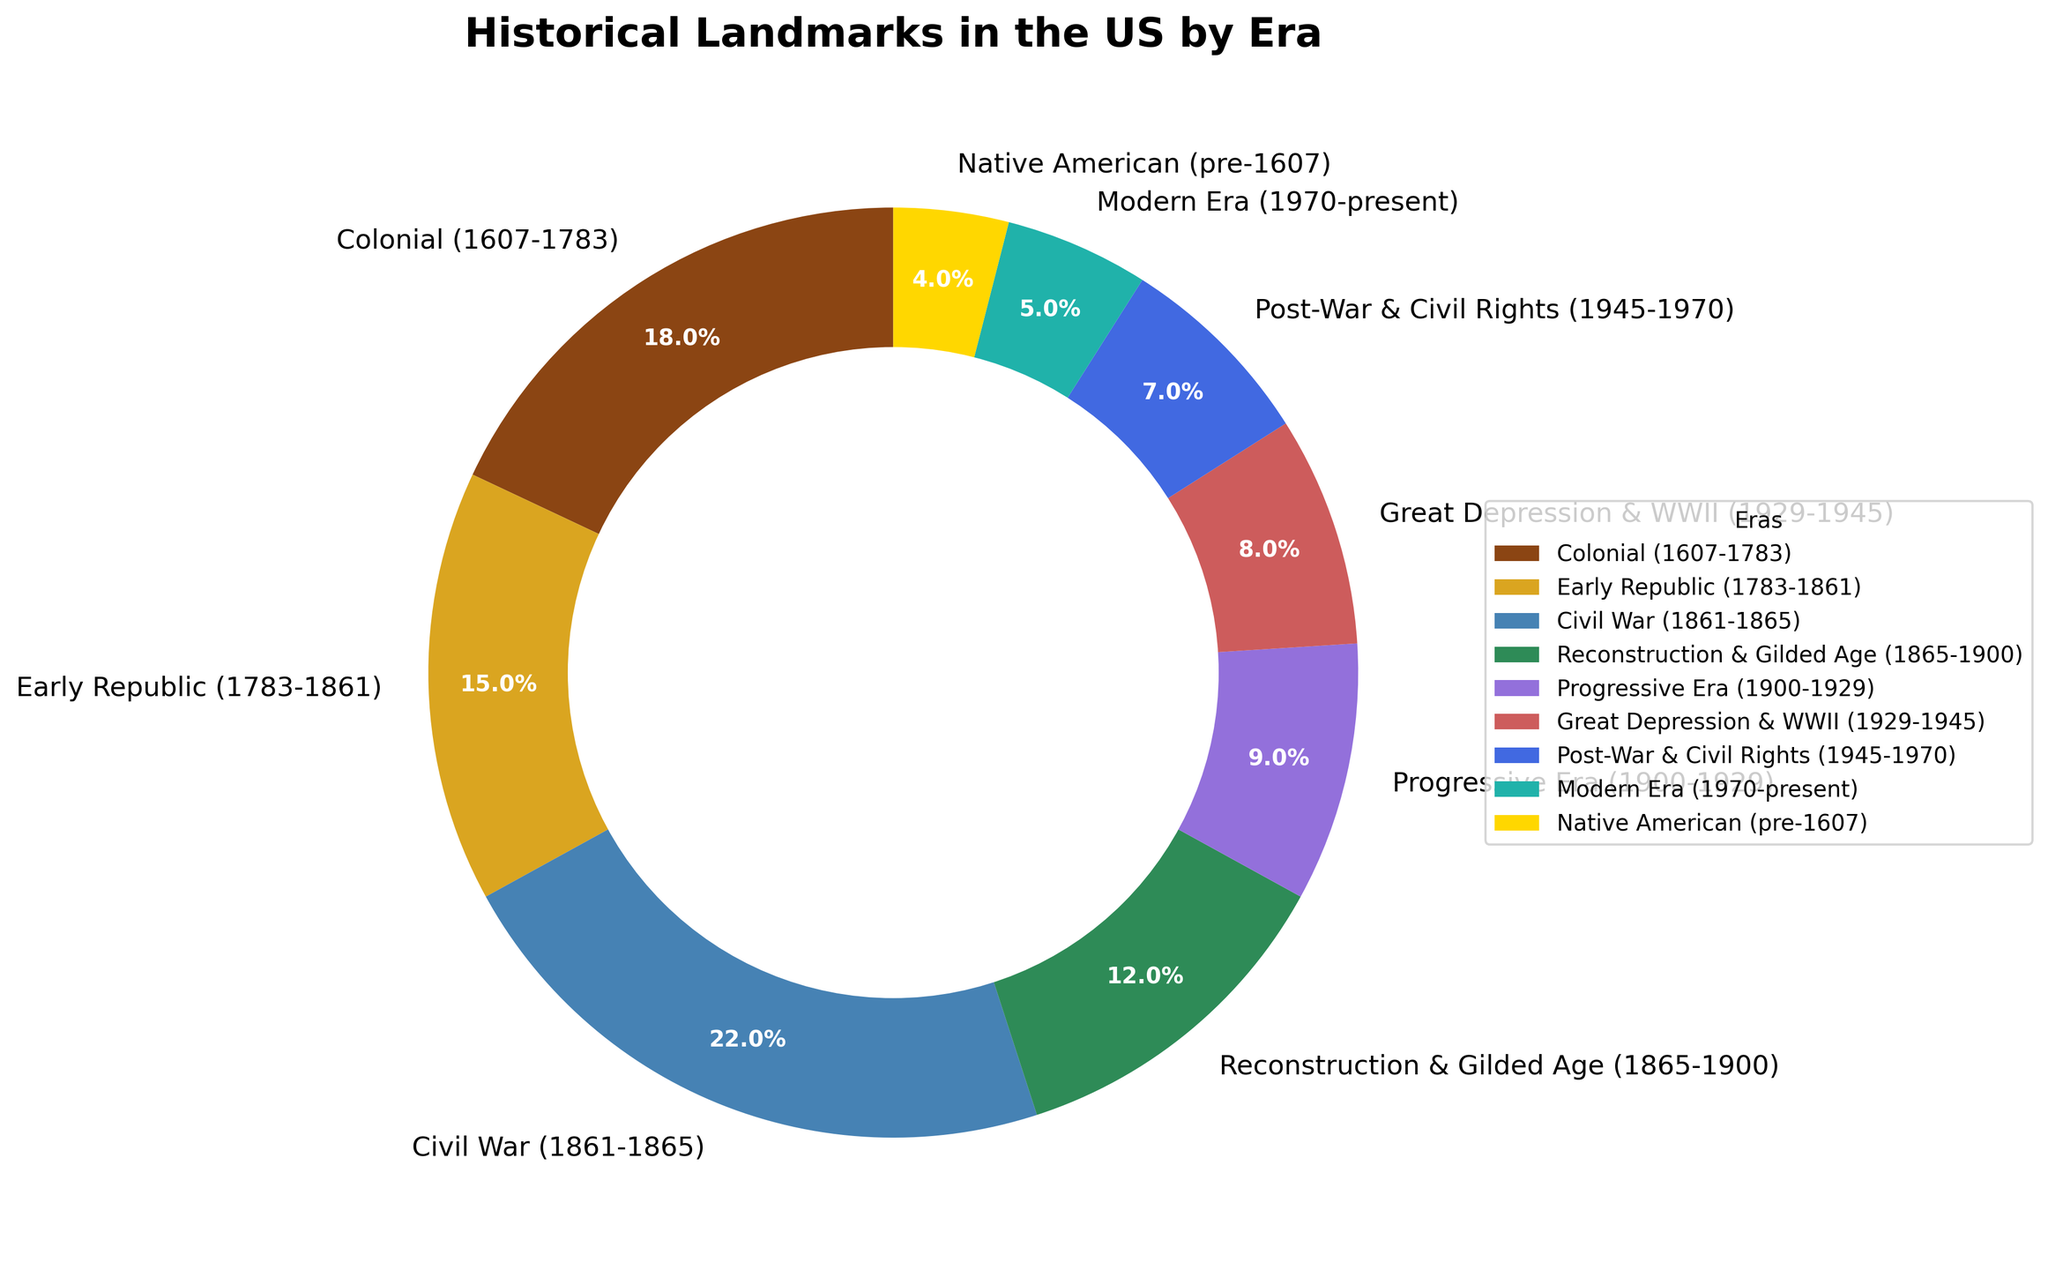Which era has the highest percentage of historical landmarks? Look at the figure, find the percentage associated with each era, and identify the highest one, which is the Civil War era with 22%.
Answer: Civil War era What's the combined percentage of historical landmarks from the Colonial and Civil War eras? Add the percentages of the Colonial and Civil War eras: 18% (Colonial) + 22% (Civil War) = 40%.
Answer: 40% How much higher is the percentage of landmarks from the Civil War era compared to the Native American era? Subtract the percentage of the Native American era from the Civil War era: 22% (Civil War) - 4% (Native American) = 18%.
Answer: 18% Which era has a higher percentage of historical landmarks: the Progressive Era or the Great Depression & WWII era? Compare the percentages: the Progressive Era has 9%, and the Great Depression & WWII era has 8%. The Progressive Era is higher.
Answer: Progressive Era What proportion of the total percentage do the Early Republic and Reconstruction & Gilded Age eras represent together? Add the percentages of the Early Republic and Reconstruction & Gilded Age eras: 15% (Early Republic) + 12% (Reconstruction & Gilded Age) = 27%.
Answer: 27% Is the percentage of landmarks from the Modern Era higher or lower than that of the Post-War & Civil Rights era? Compare the percentages: the Modern Era has 5%, and the Post-War & Civil Rights era has 7%. The Modern Era is lower.
Answer: Lower What's the difference in percentage between the era with the lowest and the era with the highest number of historical landmarks? Subtract the percentage of the era with the lowest (Modern Era, 5%) from the era with the highest (Civil War, 22%): 22% - 5% = 17%.
Answer: 17% By how many percentage points does the Early Republic era surpass the Progressive Era? Subtract the percentage of the Progressive Era from the Early Republic era: 15% (Early Republic) - 9% (Progressive Era) = 6%.
Answer: 6% If we consider eras before and after 1900, what is the combined percentage of landmarks from eras post-1900? Add the percentages of all eras after 1900: 9% (Progressive Era) + 8% (Great Depression & WWII) + 7% (Post-War & Civil Rights) + 5% (Modern Era) = 29%.
Answer: 29% Which two eras combined have a larger percentage of landmarks, the Civil War and Reconstruction & Gilded Age eras or the Post-War & Civil Rights and Modern eras? Add the percentages of Civil War and Reconstruction & Gilded Age eras: 22% + 12% = 34%. Add the percentages of Post-War & Civil Rights and Modern eras: 7% + 5% = 12%. The former combination is larger.
Answer: Civil War and Reconstruction & Gilded Age eras 